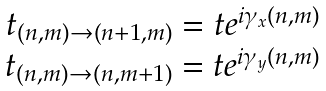<formula> <loc_0><loc_0><loc_500><loc_500>\begin{array} { c } t _ { ( n , m ) \rightarrow ( n + 1 , m ) } = t e ^ { i \gamma _ { x } ( n , m ) } \\ t _ { ( n , m ) \rightarrow ( n , m + 1 ) } = t e ^ { i \gamma _ { y } ( n , m ) } \end{array}</formula> 